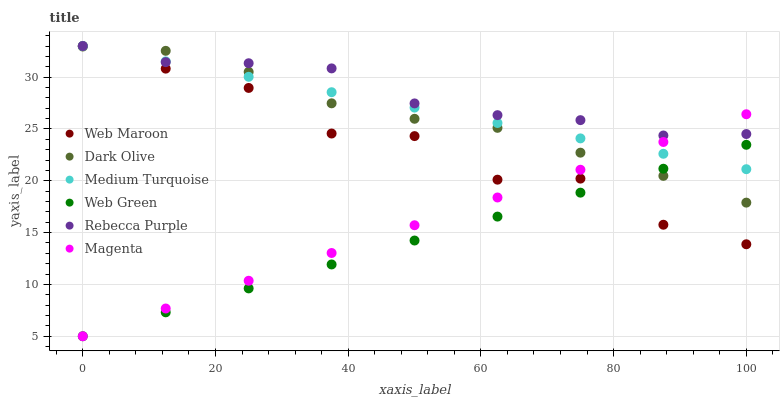Does Web Green have the minimum area under the curve?
Answer yes or no. Yes. Does Rebecca Purple have the maximum area under the curve?
Answer yes or no. Yes. Does Web Maroon have the minimum area under the curve?
Answer yes or no. No. Does Web Maroon have the maximum area under the curve?
Answer yes or no. No. Is Web Green the smoothest?
Answer yes or no. Yes. Is Web Maroon the roughest?
Answer yes or no. Yes. Is Web Maroon the smoothest?
Answer yes or no. No. Is Web Green the roughest?
Answer yes or no. No. Does Web Green have the lowest value?
Answer yes or no. Yes. Does Web Maroon have the lowest value?
Answer yes or no. No. Does Medium Turquoise have the highest value?
Answer yes or no. Yes. Does Web Green have the highest value?
Answer yes or no. No. Is Web Green less than Rebecca Purple?
Answer yes or no. Yes. Is Rebecca Purple greater than Web Green?
Answer yes or no. Yes. Does Web Green intersect Medium Turquoise?
Answer yes or no. Yes. Is Web Green less than Medium Turquoise?
Answer yes or no. No. Is Web Green greater than Medium Turquoise?
Answer yes or no. No. Does Web Green intersect Rebecca Purple?
Answer yes or no. No. 